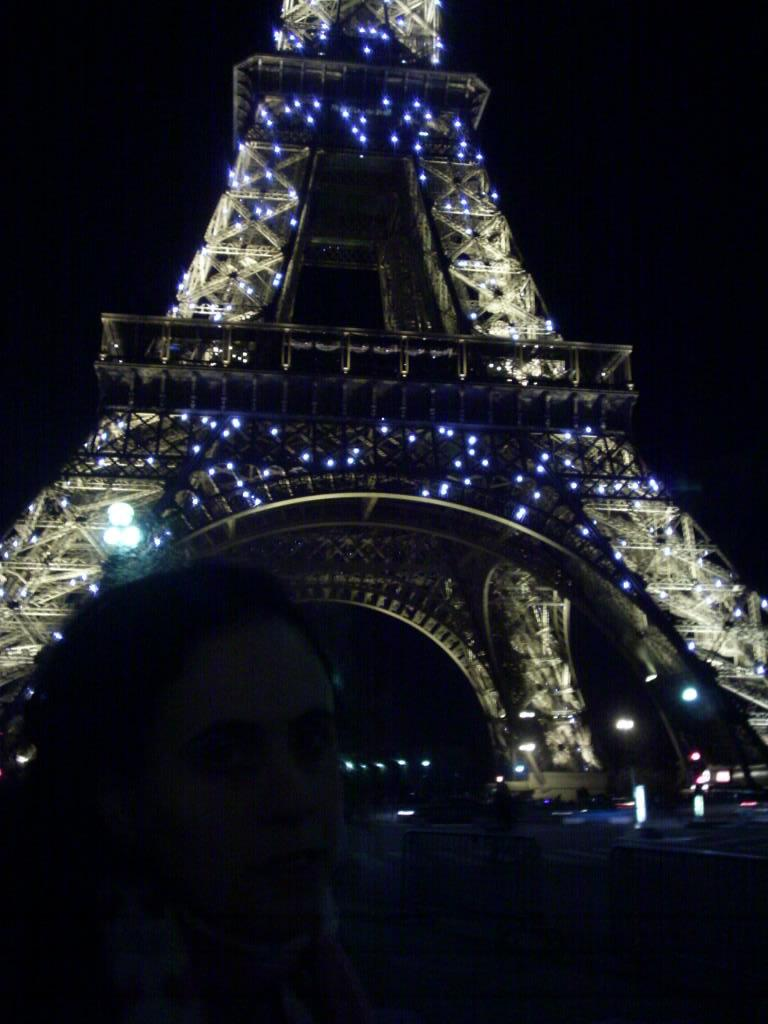What is the main structure in the image? There is a tower in the image. Are there any other elements visible in the image besides the tower? Yes, there are lights in the image. How would you describe the overall appearance of the image? The background of the image is dark. How many clams can be seen on the tower in the image? There are no clams present on the tower in the image. Is the rock visible in the image? There is no rock visible in the image. 